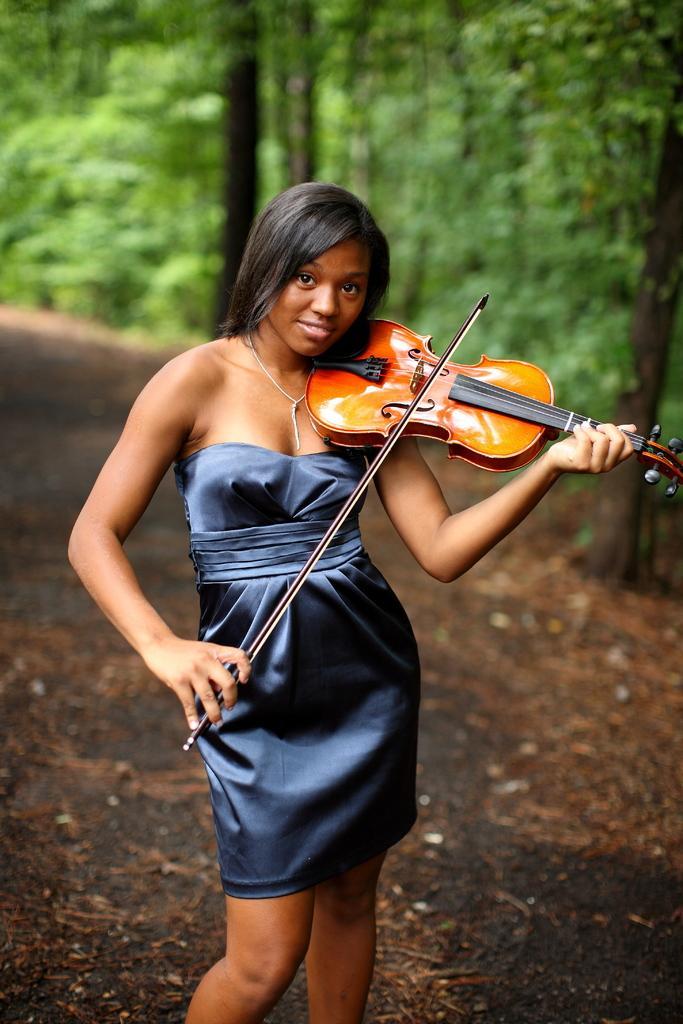Please provide a concise description of this image. In the picture I can see a woman wearing blue dress is standing and playing violin and there are trees in the background. 